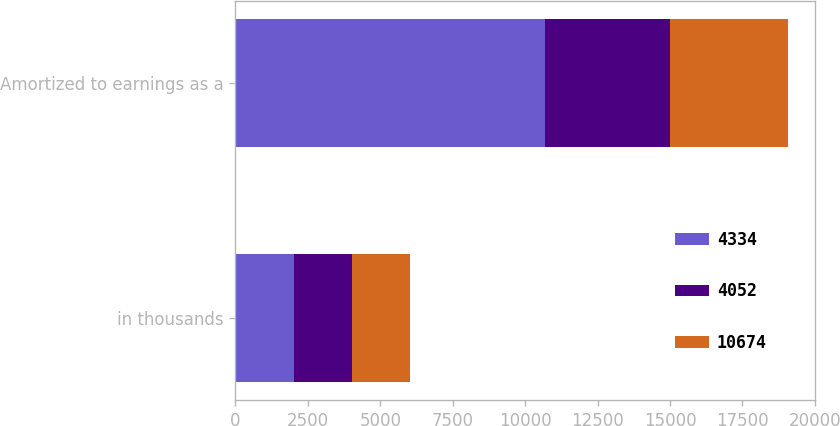<chart> <loc_0><loc_0><loc_500><loc_500><stacked_bar_chart><ecel><fcel>in thousands<fcel>Amortized to earnings as a<nl><fcel>4334<fcel>2014<fcel>10674<nl><fcel>4052<fcel>2013<fcel>4334<nl><fcel>10674<fcel>2012<fcel>4052<nl></chart> 